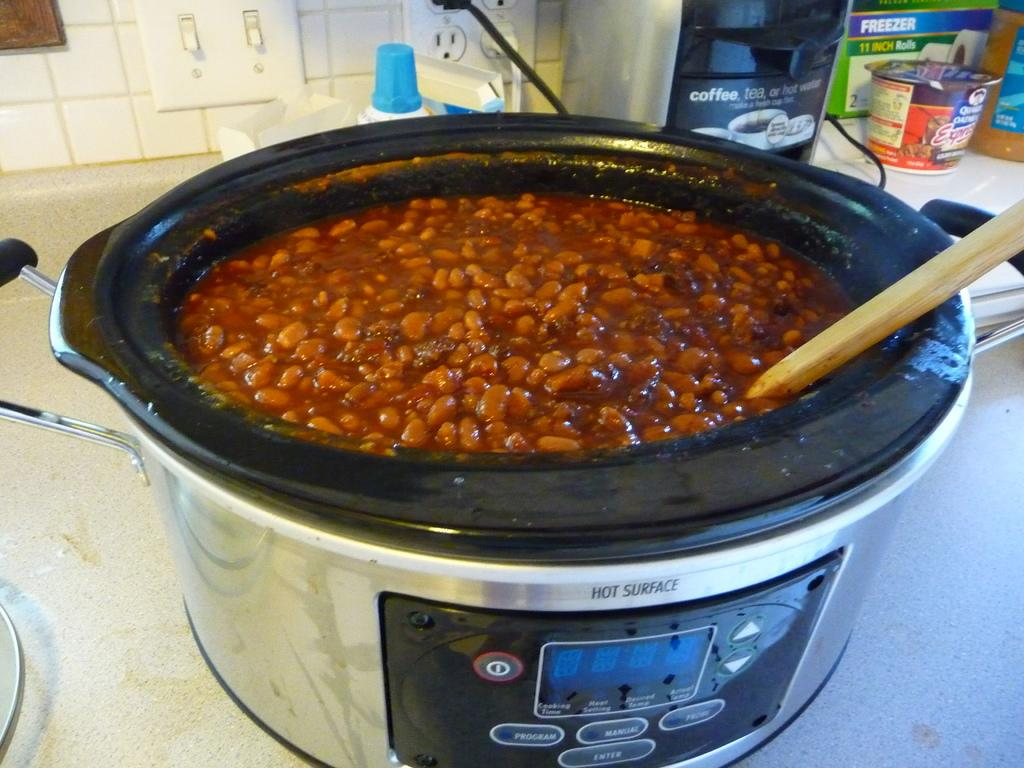Provide a one-sentence caption for the provided image. Inside a slow cooker with a hot surface warning on the front, has a full batch of baked beans inside it. 